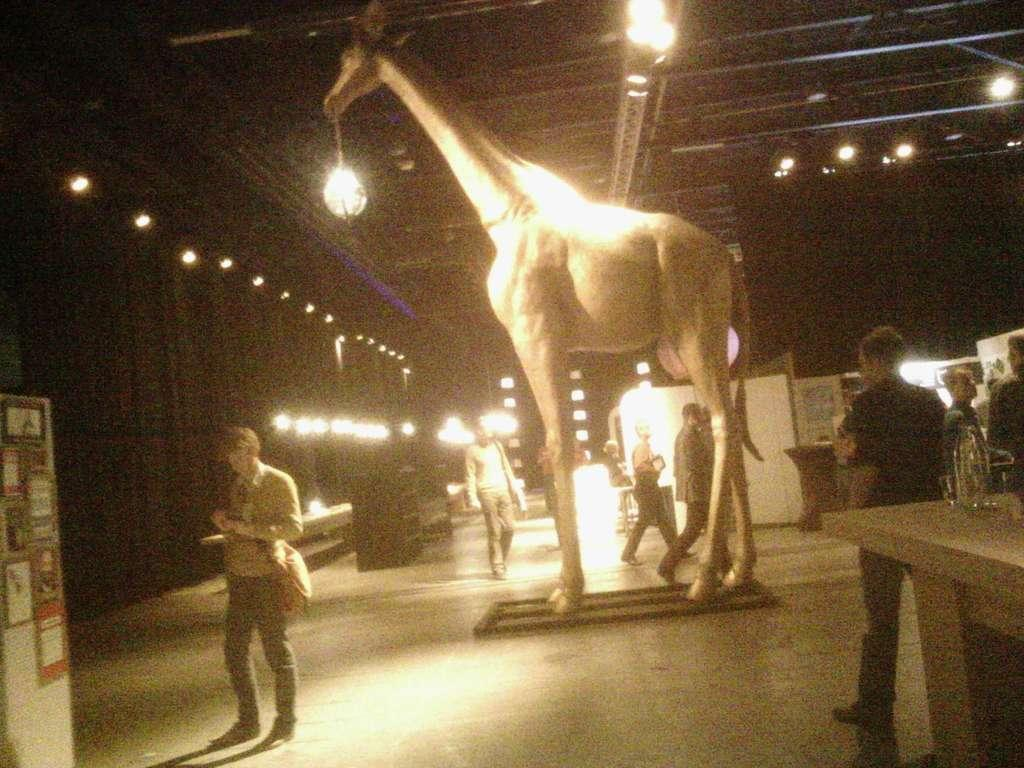Where was the image taken? The image was taken inside a building. Who or what can be seen in the image? There are people in the image. What is on the roof in the image? There are lights on the roof. What is located on the bottom left of the image? There is a board on the bottom left of the image. What type of animal is depicted as a statue in the image? There is a statue of a giraffe in the image. What piece of furniture is present in the image? There is a table in the image. What is the title of the book being read by the person in the image? There is no book or person reading a book visible in the image. Can you tell me how many cloths are draped over the table in the image? There are no cloths draped over the table in the image. 